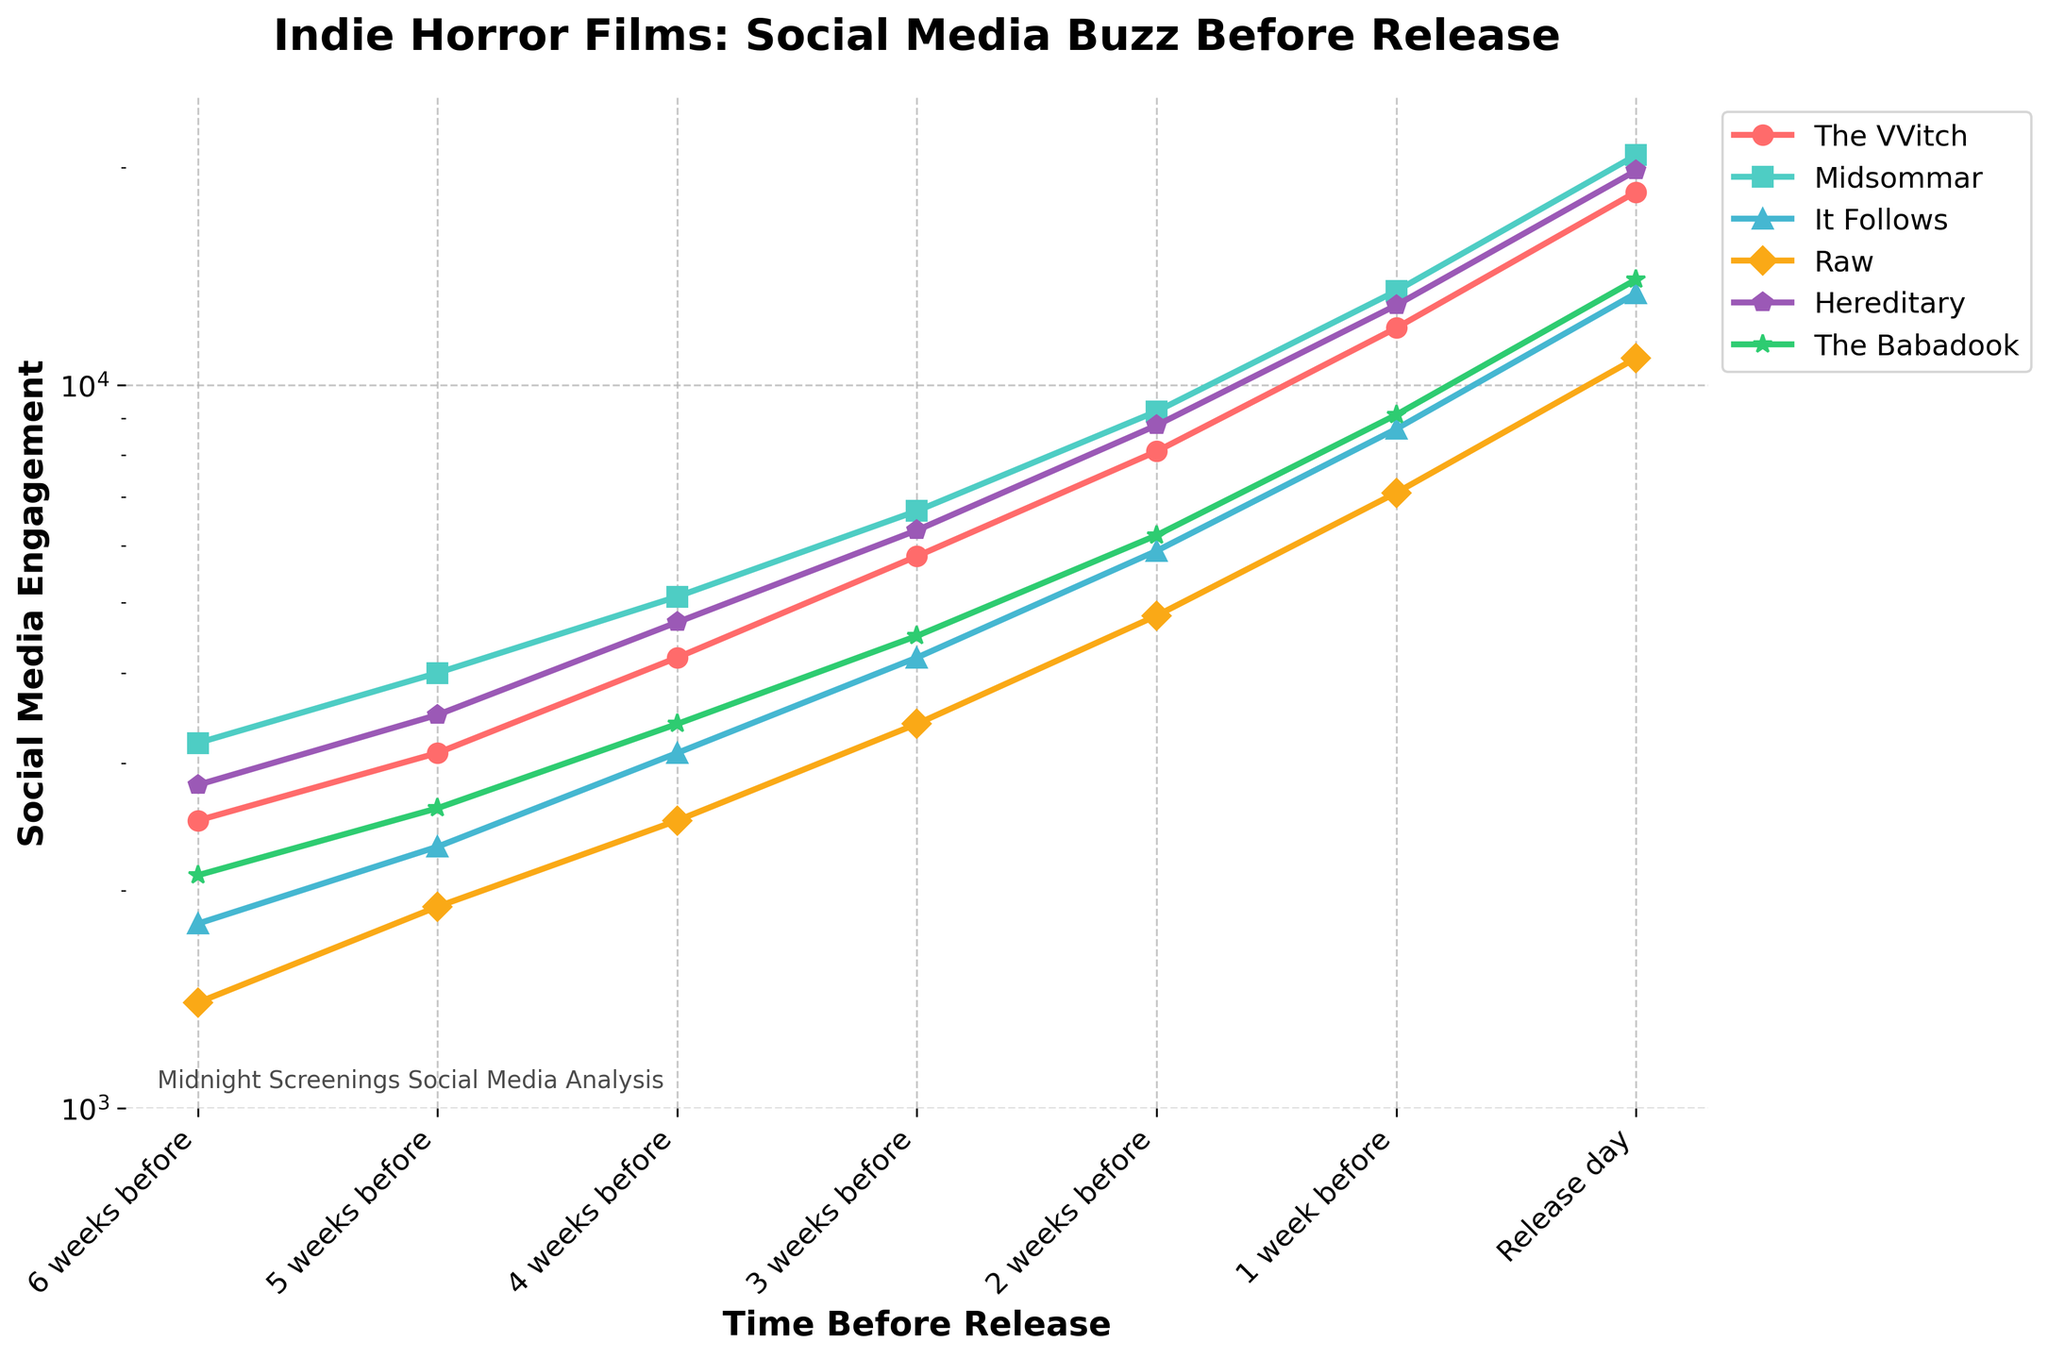What's the trend of social media engagement for 'Hereditary' in the weeks leading up to its release? The engagement starts from 2800 six weeks before release and steadily increases, reaching 19800 on release day. The increase is smooth without any drops, indicating growing interest each week.
Answer: It increases steadily Which film had the highest social media engagement on release day? On release day, 'Midsommar' had the highest engagement with a value of 20800, as indicated by the highest point on the chart.
Answer: Midsommar Compare the social media engagement for 'It Follows' and 'Raw' three weeks before their release. Which film had higher engagement? At three weeks before release, 'It Follows' had 4200 engagements and 'Raw' had 3400, so 'It Follows' had higher engagement.
Answer: It Follows How does the engagement pattern of 'Midsommar' compare to 'The Babadook' throughout the six weeks? 'Midsommar' consistently has higher engagement than 'The Babadook' throughout all weeks, starting from 3200 versus 2100 six weeks before, up to 20800 versus 14000 on release day.
Answer: Midsommar consistently higher What can be inferred about the popularity trends of 'The VVitch' versus 'Raw' over time? 'The VVitch' starts and ends with higher engagement than 'Raw,' starting at 2500 vs 1400 and rising to 18500 vs 10900. Both films show increasing trends, but 'The VVitch' has a steeper growth in engagement.
Answer: The VVitch more popular Is there any film that had a noticeable drop in social media engagement at any point in the given timeframe? No film had a drop; all the films show an upward trend in engagement week by week, indicating consistent interest growth.
Answer: No Which film had the lowest social media engagement 2 weeks before release, and what was the value? Two weeks before release, 'Raw' had the lowest engagement with 4800.
Answer: Raw, 4800 